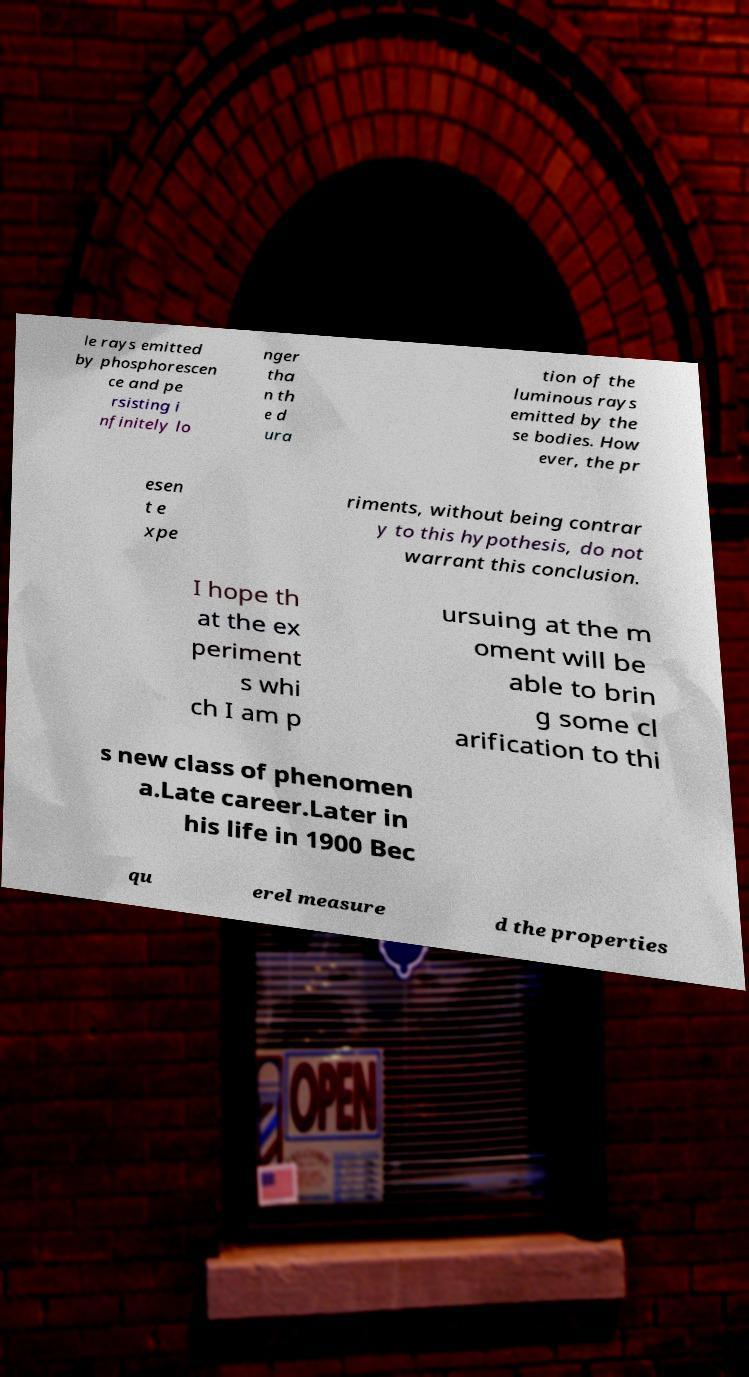Could you assist in decoding the text presented in this image and type it out clearly? le rays emitted by phosphorescen ce and pe rsisting i nfinitely lo nger tha n th e d ura tion of the luminous rays emitted by the se bodies. How ever, the pr esen t e xpe riments, without being contrar y to this hypothesis, do not warrant this conclusion. I hope th at the ex periment s whi ch I am p ursuing at the m oment will be able to brin g some cl arification to thi s new class of phenomen a.Late career.Later in his life in 1900 Bec qu erel measure d the properties 